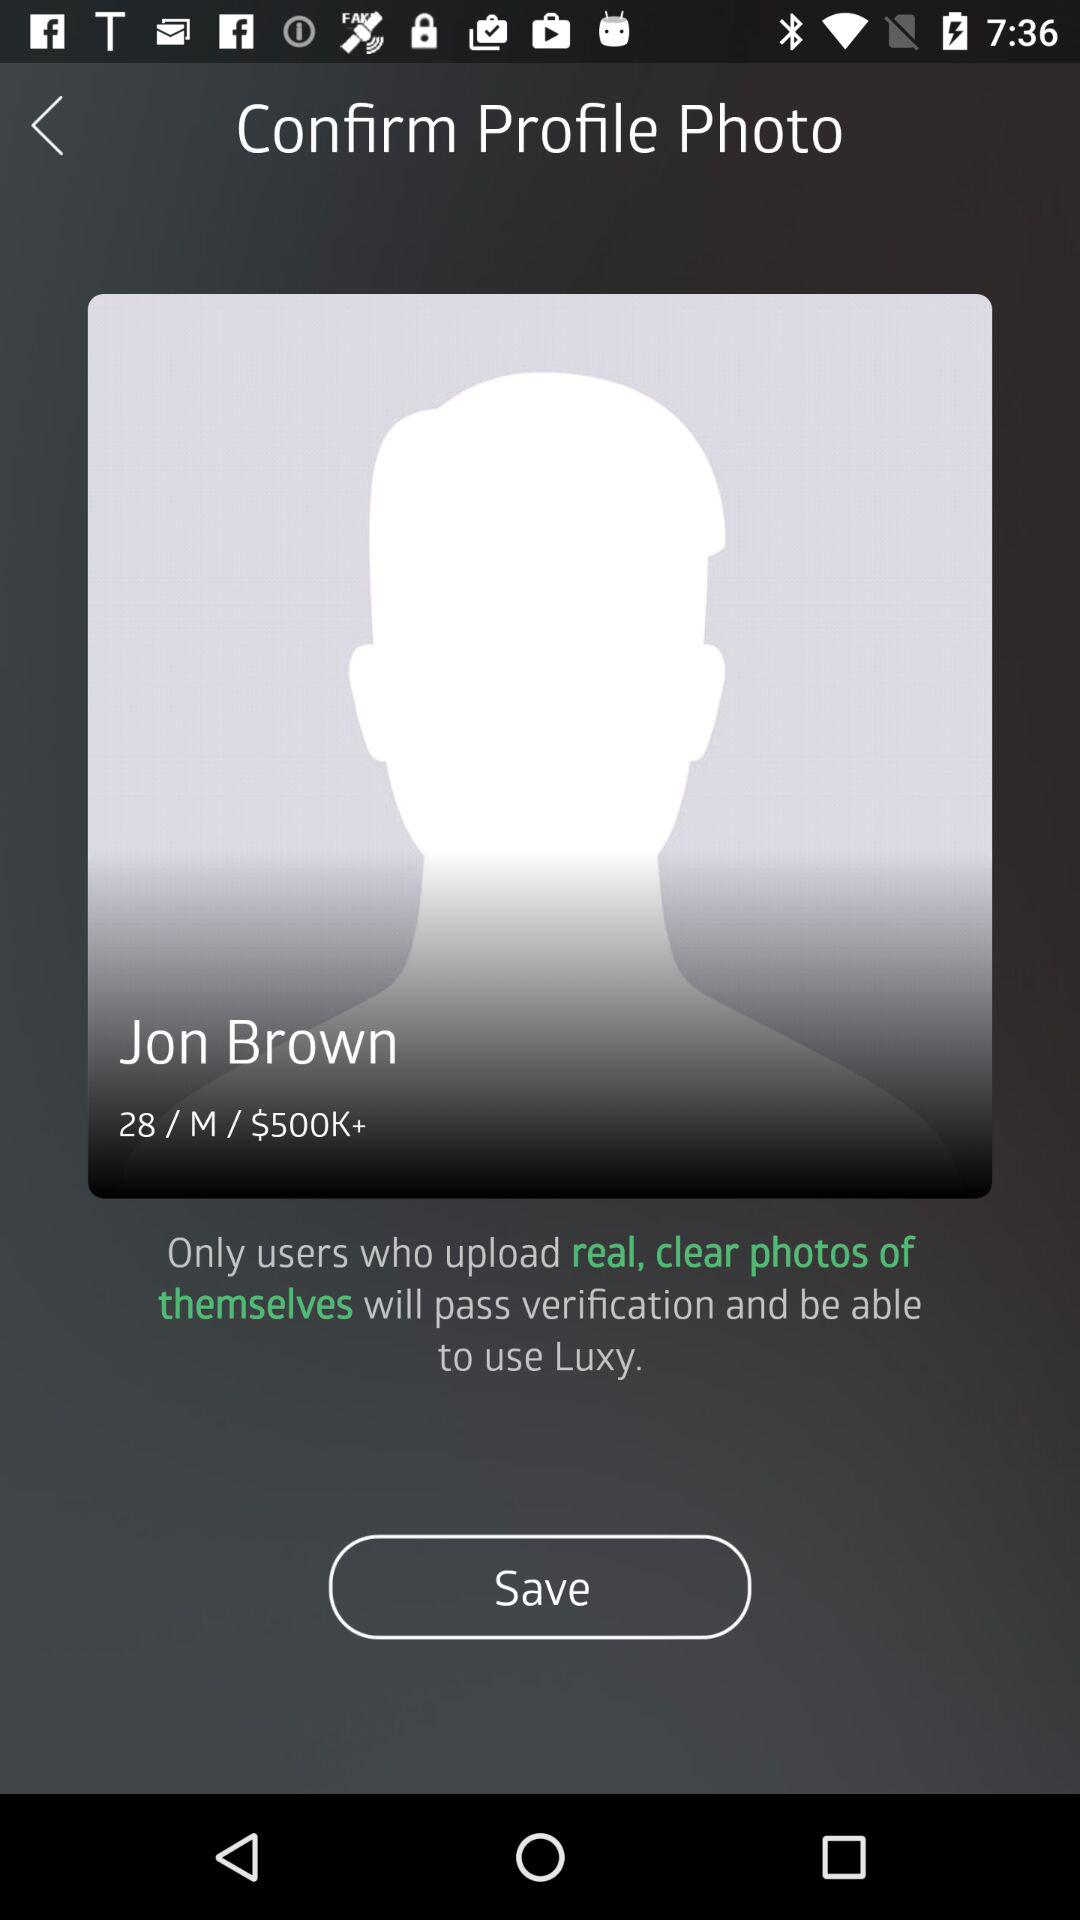What is the age of Jon Brown? Jon Brown is 28 years old. 